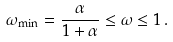Convert formula to latex. <formula><loc_0><loc_0><loc_500><loc_500>\omega _ { \min } = \frac { \alpha } { 1 + \alpha } \leq \omega \leq 1 \, .</formula> 